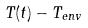Convert formula to latex. <formula><loc_0><loc_0><loc_500><loc_500>T ( t ) - T _ { e n v }</formula> 